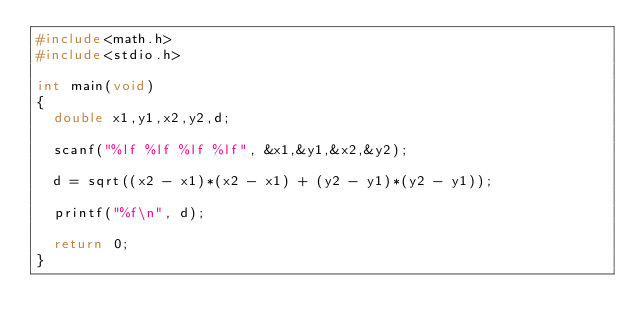Convert code to text. <code><loc_0><loc_0><loc_500><loc_500><_C_>#include<math.h>
#include<stdio.h>

int main(void)
{
	double x1,y1,x2,y2,d;

	scanf("%lf %lf %lf %lf", &x1,&y1,&x2,&y2);

	d = sqrt((x2 - x1)*(x2 - x1) + (y2 - y1)*(y2 - y1));

	printf("%f\n", d);

	return 0;
}
</code> 